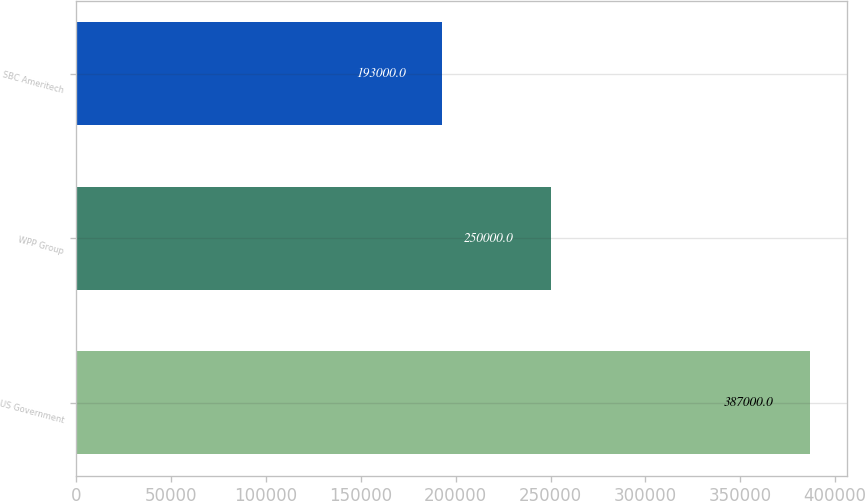<chart> <loc_0><loc_0><loc_500><loc_500><bar_chart><fcel>US Government<fcel>WPP Group<fcel>SBC Ameritech<nl><fcel>387000<fcel>250000<fcel>193000<nl></chart> 